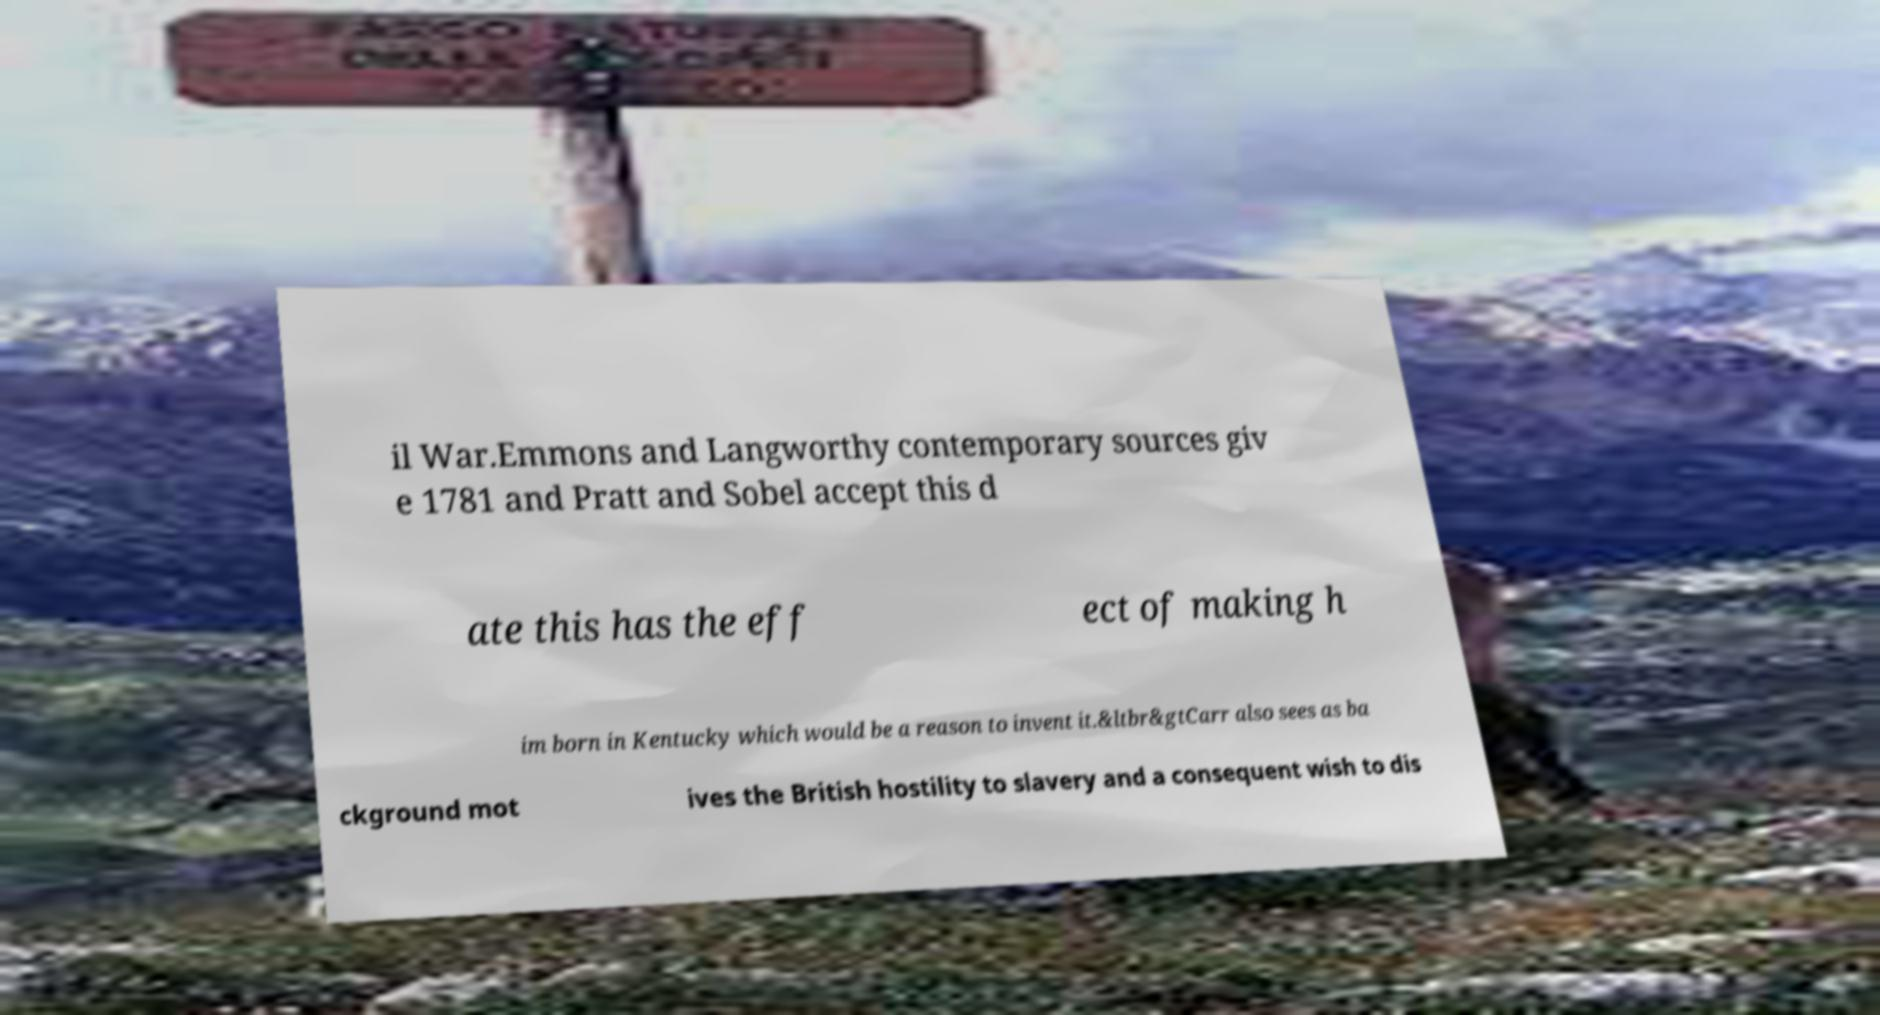Can you accurately transcribe the text from the provided image for me? il War.Emmons and Langworthy contemporary sources giv e 1781 and Pratt and Sobel accept this d ate this has the eff ect of making h im born in Kentucky which would be a reason to invent it.&ltbr&gtCarr also sees as ba ckground mot ives the British hostility to slavery and a consequent wish to dis 